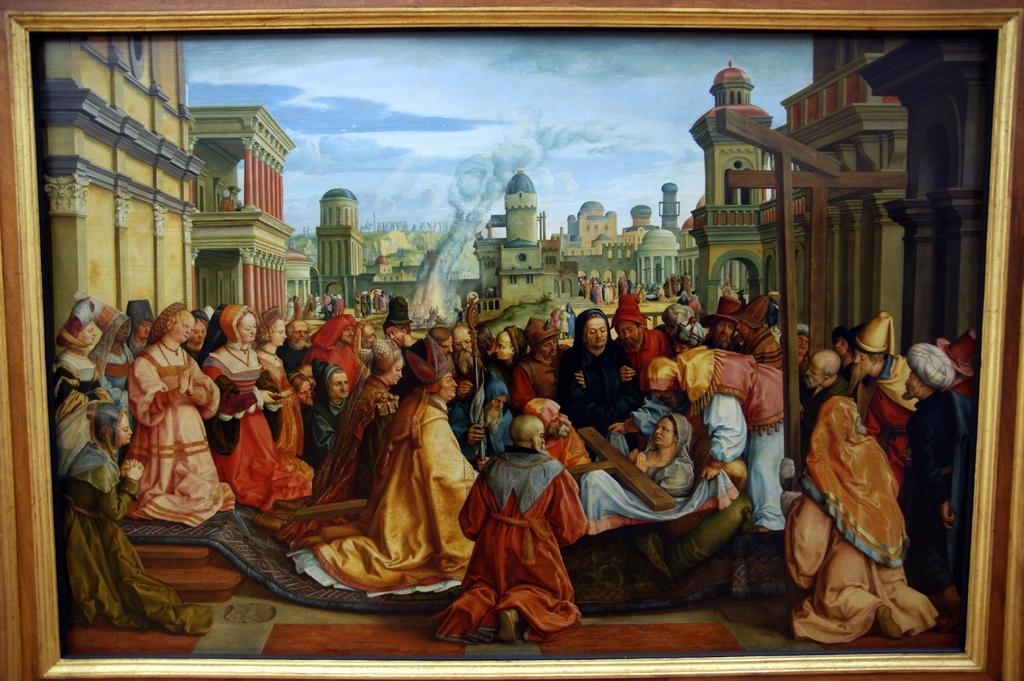Can you describe this image briefly? This image consists of a picture frame. In this image there are many people sitting on the floor and a few are standing. At the top of the image there is the sky with clouds. In the background there are many buildings with walls, windows, pillars, doors and roofs. 